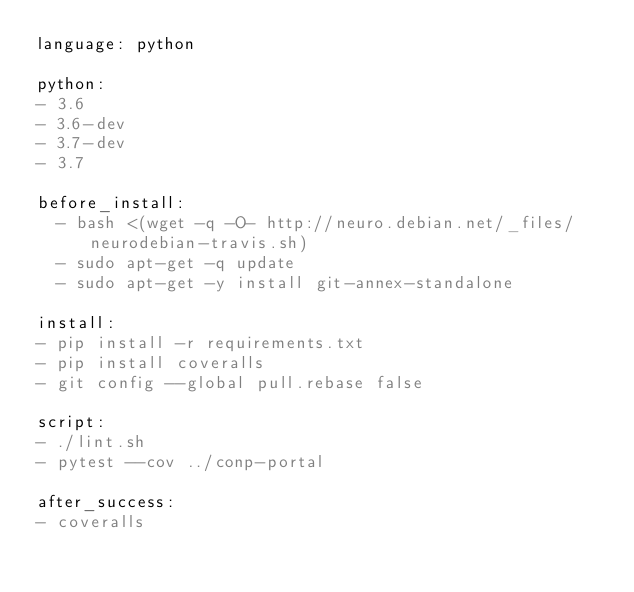Convert code to text. <code><loc_0><loc_0><loc_500><loc_500><_YAML_>language: python

python:
- 3.6
- 3.6-dev
- 3.7-dev
- 3.7

before_install:
  - bash <(wget -q -O- http://neuro.debian.net/_files/neurodebian-travis.sh)
  - sudo apt-get -q update
  - sudo apt-get -y install git-annex-standalone

install:
- pip install -r requirements.txt
- pip install coveralls
- git config --global pull.rebase false

script:
- ./lint.sh
- pytest --cov ../conp-portal

after_success:
- coveralls
</code> 